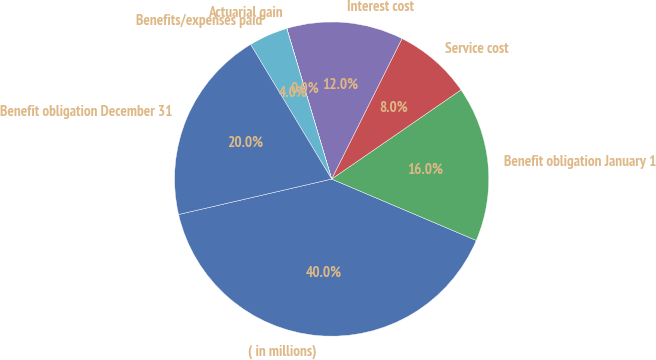Convert chart to OTSL. <chart><loc_0><loc_0><loc_500><loc_500><pie_chart><fcel>( in millions)<fcel>Benefit obligation January 1<fcel>Service cost<fcel>Interest cost<fcel>Actuarial gain<fcel>Benefits/expenses paid<fcel>Benefit obligation December 31<nl><fcel>39.99%<fcel>16.0%<fcel>8.0%<fcel>12.0%<fcel>0.01%<fcel>4.01%<fcel>20.0%<nl></chart> 